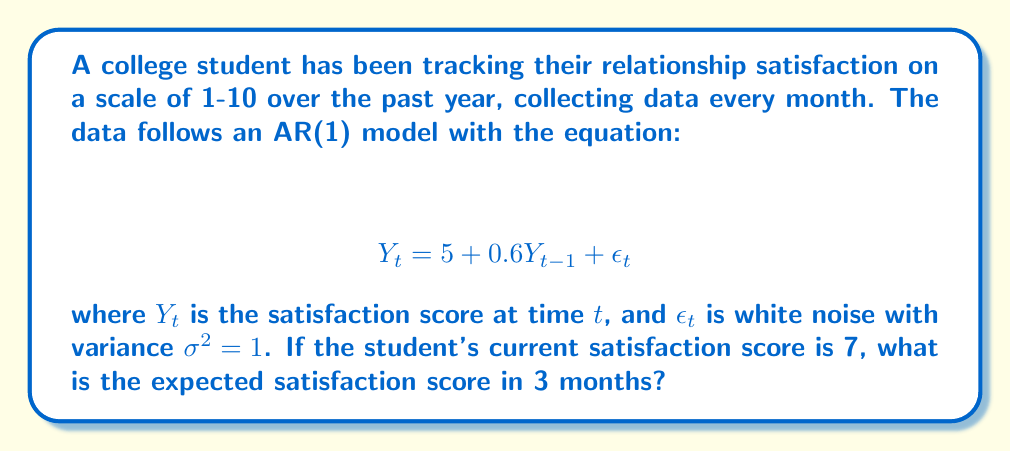Can you solve this math problem? To solve this problem, we need to use the properties of the AR(1) model and iterate the equation for future time periods. Let's break it down step by step:

1. We start with the given AR(1) model:
   $$ Y_t = 5 + 0.6Y_{t-1} + \epsilon_t $$

2. We need to find $E[Y_{t+3}|Y_t = 7]$, where $t$ is the current time.

3. For an AR(1) model, we can calculate future expectations using the following formula:
   $$ E[Y_{t+k}|Y_t] = \mu + \phi^k(Y_t - \mu) $$
   where $\mu$ is the mean of the process, $\phi$ is the AR coefficient, and $k$ is the number of steps ahead.

4. In our case:
   - $\mu = \frac{5}{1-0.6} = 12.5$ (the long-term mean of the process)
   - $\phi = 0.6$
   - $k = 3$
   - $Y_t = 7$

5. Plugging these values into the formula:
   $$ E[Y_{t+3}|Y_t = 7] = 12.5 + 0.6^3(7 - 12.5) $$

6. Simplify:
   $$ E[Y_{t+3}|Y_t = 7] = 12.5 + 0.216(-5.5) = 12.5 - 1.188 = 11.312 $$

Therefore, the expected satisfaction score in 3 months is approximately 11.312.
Answer: 11.312 